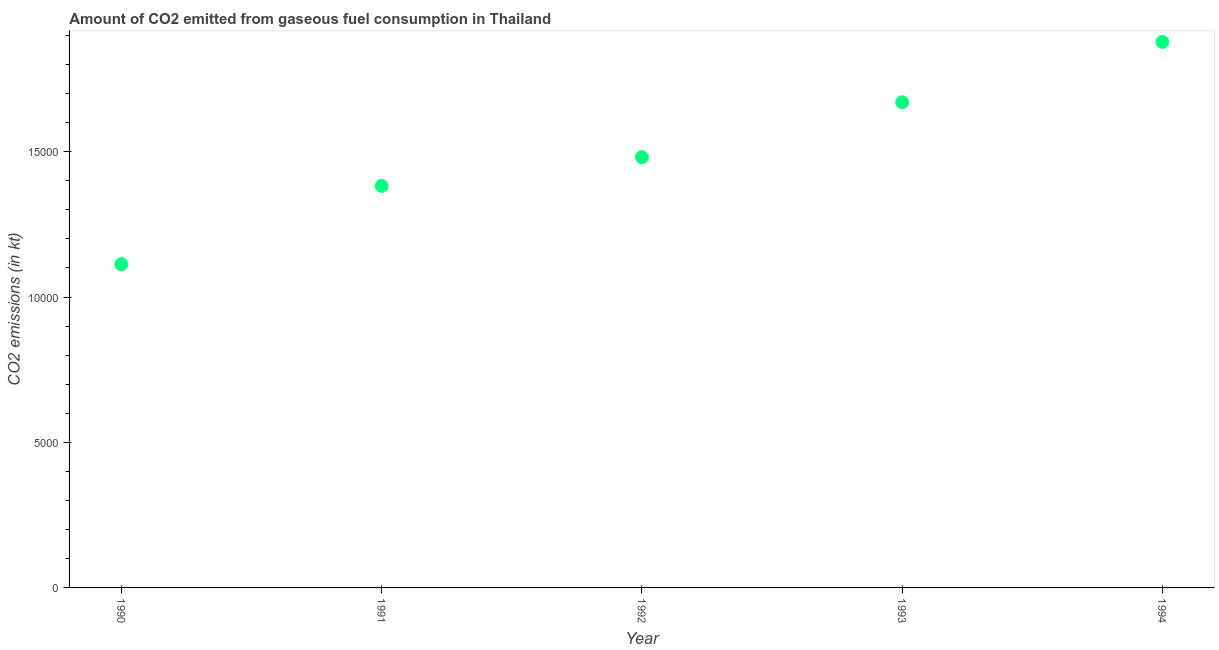What is the co2 emissions from gaseous fuel consumption in 1990?
Give a very brief answer. 1.11e+04. Across all years, what is the maximum co2 emissions from gaseous fuel consumption?
Make the answer very short. 1.88e+04. Across all years, what is the minimum co2 emissions from gaseous fuel consumption?
Give a very brief answer. 1.11e+04. In which year was the co2 emissions from gaseous fuel consumption minimum?
Your answer should be compact. 1990. What is the sum of the co2 emissions from gaseous fuel consumption?
Offer a terse response. 7.53e+04. What is the difference between the co2 emissions from gaseous fuel consumption in 1990 and 1992?
Give a very brief answer. -3685.34. What is the average co2 emissions from gaseous fuel consumption per year?
Provide a succinct answer. 1.51e+04. What is the median co2 emissions from gaseous fuel consumption?
Your answer should be very brief. 1.48e+04. Do a majority of the years between 1992 and 1991 (inclusive) have co2 emissions from gaseous fuel consumption greater than 18000 kt?
Provide a succinct answer. No. What is the ratio of the co2 emissions from gaseous fuel consumption in 1990 to that in 1992?
Make the answer very short. 0.75. Is the co2 emissions from gaseous fuel consumption in 1991 less than that in 1994?
Make the answer very short. Yes. Is the difference between the co2 emissions from gaseous fuel consumption in 1990 and 1994 greater than the difference between any two years?
Your answer should be very brief. Yes. What is the difference between the highest and the second highest co2 emissions from gaseous fuel consumption?
Give a very brief answer. 2079.19. Is the sum of the co2 emissions from gaseous fuel consumption in 1992 and 1993 greater than the maximum co2 emissions from gaseous fuel consumption across all years?
Offer a terse response. Yes. What is the difference between the highest and the lowest co2 emissions from gaseous fuel consumption?
Keep it short and to the point. 7653.03. In how many years, is the co2 emissions from gaseous fuel consumption greater than the average co2 emissions from gaseous fuel consumption taken over all years?
Ensure brevity in your answer.  2. How many years are there in the graph?
Your answer should be compact. 5. Are the values on the major ticks of Y-axis written in scientific E-notation?
Your answer should be compact. No. Does the graph contain grids?
Your response must be concise. No. What is the title of the graph?
Offer a terse response. Amount of CO2 emitted from gaseous fuel consumption in Thailand. What is the label or title of the Y-axis?
Your answer should be compact. CO2 emissions (in kt). What is the CO2 emissions (in kt) in 1990?
Keep it short and to the point. 1.11e+04. What is the CO2 emissions (in kt) in 1991?
Give a very brief answer. 1.38e+04. What is the CO2 emissions (in kt) in 1992?
Your answer should be compact. 1.48e+04. What is the CO2 emissions (in kt) in 1993?
Keep it short and to the point. 1.67e+04. What is the CO2 emissions (in kt) in 1994?
Ensure brevity in your answer.  1.88e+04. What is the difference between the CO2 emissions (in kt) in 1990 and 1991?
Your response must be concise. -2695.24. What is the difference between the CO2 emissions (in kt) in 1990 and 1992?
Provide a succinct answer. -3685.34. What is the difference between the CO2 emissions (in kt) in 1990 and 1993?
Your answer should be very brief. -5573.84. What is the difference between the CO2 emissions (in kt) in 1990 and 1994?
Provide a succinct answer. -7653.03. What is the difference between the CO2 emissions (in kt) in 1991 and 1992?
Offer a terse response. -990.09. What is the difference between the CO2 emissions (in kt) in 1991 and 1993?
Your answer should be very brief. -2878.59. What is the difference between the CO2 emissions (in kt) in 1991 and 1994?
Provide a succinct answer. -4957.78. What is the difference between the CO2 emissions (in kt) in 1992 and 1993?
Your answer should be compact. -1888.51. What is the difference between the CO2 emissions (in kt) in 1992 and 1994?
Your response must be concise. -3967.69. What is the difference between the CO2 emissions (in kt) in 1993 and 1994?
Offer a terse response. -2079.19. What is the ratio of the CO2 emissions (in kt) in 1990 to that in 1991?
Your response must be concise. 0.81. What is the ratio of the CO2 emissions (in kt) in 1990 to that in 1992?
Your answer should be very brief. 0.75. What is the ratio of the CO2 emissions (in kt) in 1990 to that in 1993?
Make the answer very short. 0.67. What is the ratio of the CO2 emissions (in kt) in 1990 to that in 1994?
Keep it short and to the point. 0.59. What is the ratio of the CO2 emissions (in kt) in 1991 to that in 1992?
Keep it short and to the point. 0.93. What is the ratio of the CO2 emissions (in kt) in 1991 to that in 1993?
Keep it short and to the point. 0.83. What is the ratio of the CO2 emissions (in kt) in 1991 to that in 1994?
Make the answer very short. 0.74. What is the ratio of the CO2 emissions (in kt) in 1992 to that in 1993?
Offer a terse response. 0.89. What is the ratio of the CO2 emissions (in kt) in 1992 to that in 1994?
Offer a very short reply. 0.79. What is the ratio of the CO2 emissions (in kt) in 1993 to that in 1994?
Offer a terse response. 0.89. 